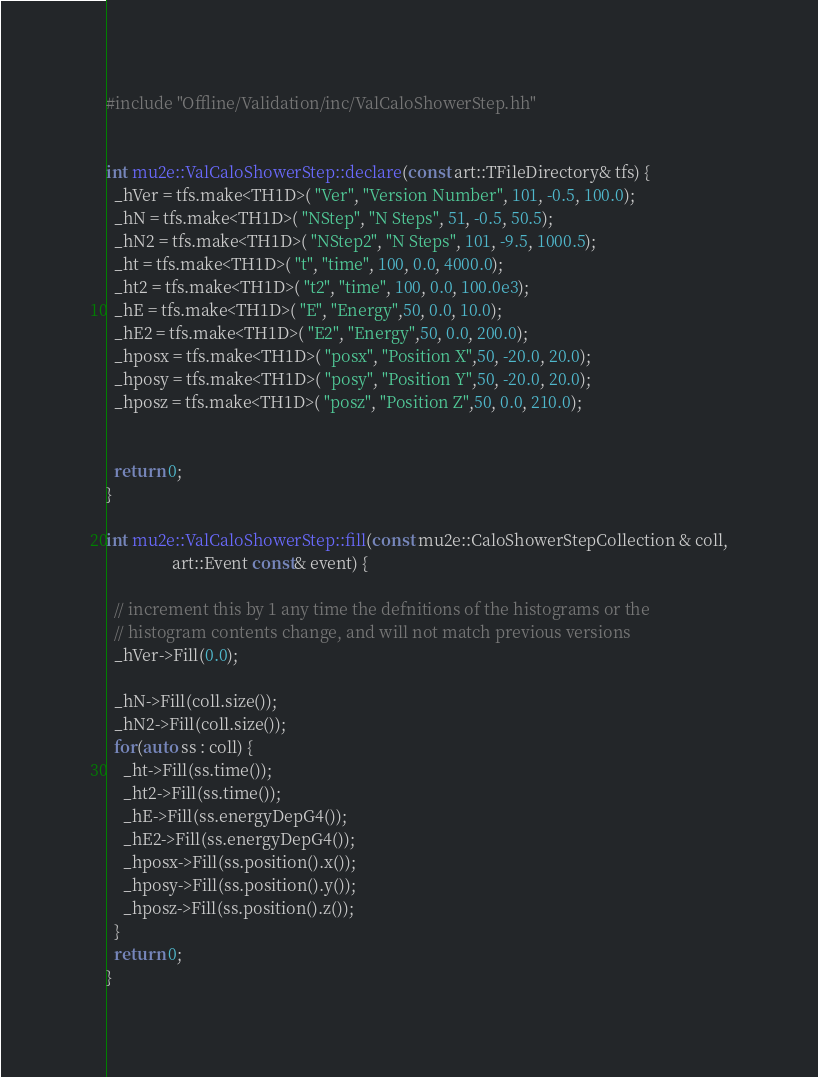Convert code to text. <code><loc_0><loc_0><loc_500><loc_500><_C++_>
#include "Offline/Validation/inc/ValCaloShowerStep.hh"


int mu2e::ValCaloShowerStep::declare(const art::TFileDirectory& tfs) {
  _hVer = tfs.make<TH1D>( "Ver", "Version Number", 101, -0.5, 100.0);
  _hN = tfs.make<TH1D>( "NStep", "N Steps", 51, -0.5, 50.5);
  _hN2 = tfs.make<TH1D>( "NStep2", "N Steps", 101, -9.5, 1000.5);
  _ht = tfs.make<TH1D>( "t", "time", 100, 0.0, 4000.0);
  _ht2 = tfs.make<TH1D>( "t2", "time", 100, 0.0, 100.0e3);
  _hE = tfs.make<TH1D>( "E", "Energy",50, 0.0, 10.0);
  _hE2 = tfs.make<TH1D>( "E2", "Energy",50, 0.0, 200.0);
  _hposx = tfs.make<TH1D>( "posx", "Position X",50, -20.0, 20.0);
  _hposy = tfs.make<TH1D>( "posy", "Position Y",50, -20.0, 20.0);
  _hposz = tfs.make<TH1D>( "posz", "Position Z",50, 0.0, 210.0);


  return 0;
}

int mu2e::ValCaloShowerStep::fill(const mu2e::CaloShowerStepCollection & coll,
				art::Event const& event) {

  // increment this by 1 any time the defnitions of the histograms or the
  // histogram contents change, and will not match previous versions
  _hVer->Fill(0.0);

  _hN->Fill(coll.size());
  _hN2->Fill(coll.size());
  for(auto ss : coll) {
    _ht->Fill(ss.time());
    _ht2->Fill(ss.time());
    _hE->Fill(ss.energyDepG4());
    _hE2->Fill(ss.energyDepG4());
    _hposx->Fill(ss.position().x());
    _hposy->Fill(ss.position().y());
    _hposz->Fill(ss.position().z());
  }
  return 0;
}
</code> 